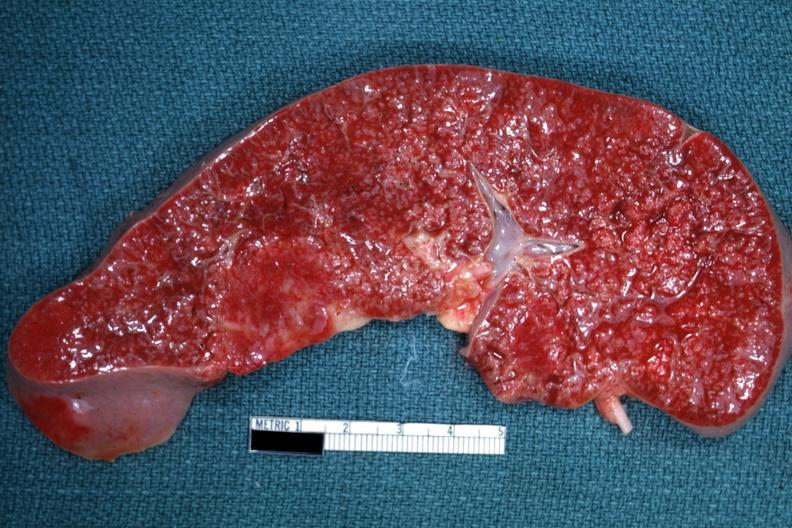s side showing patency right side present?
Answer the question using a single word or phrase. No 